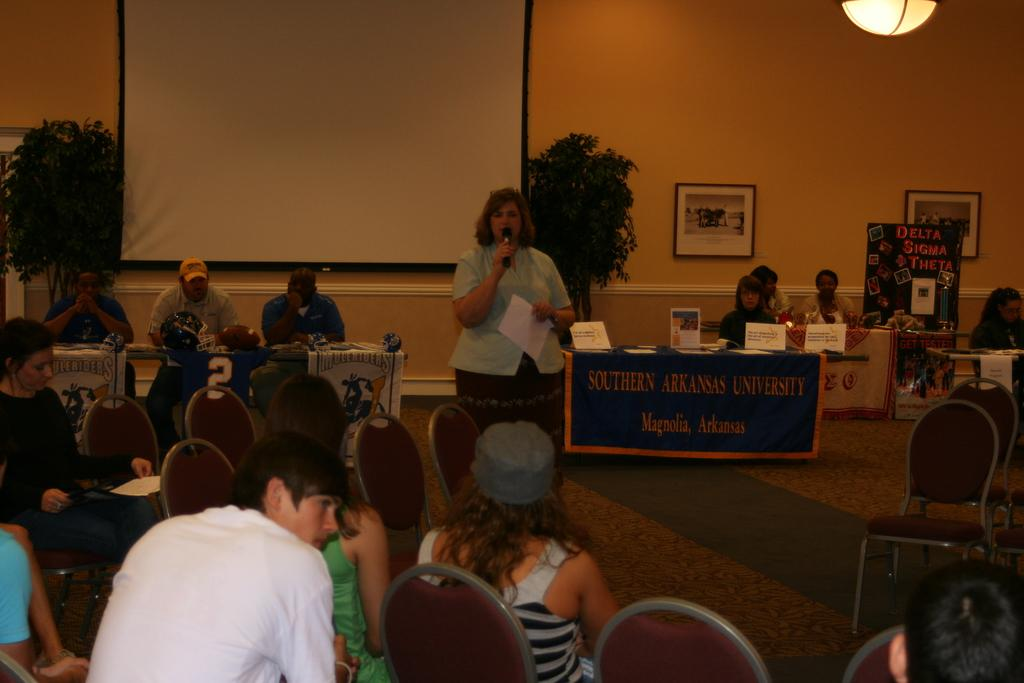Who are the subjects in the image? There are people in the image. What is the woman holding in her hand? The woman is holding a mic in her hand. What is the woman doing with the mic? The woman is speaking or performing with the mic. Can you describe the setting of the image? There are other people in the background of the image. What news is the woman sharing in the image? There is no indication in the image that the woman is sharing news. 